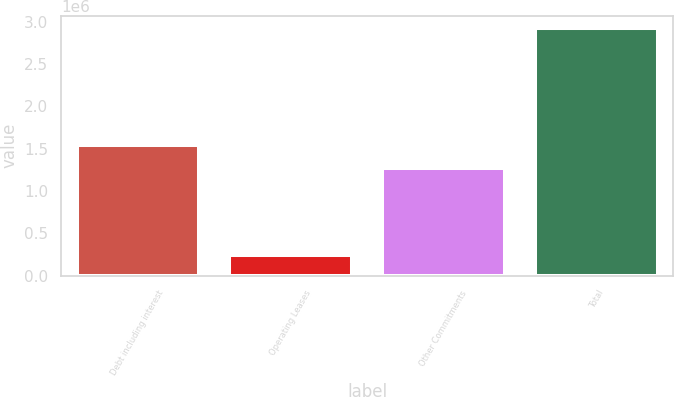<chart> <loc_0><loc_0><loc_500><loc_500><bar_chart><fcel>Debt including interest<fcel>Operating Leases<fcel>Other Commitments<fcel>Total<nl><fcel>1.54028e+06<fcel>239803<fcel>1.27207e+06<fcel>2.92192e+06<nl></chart> 